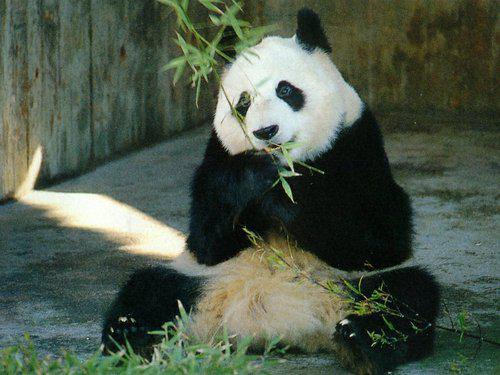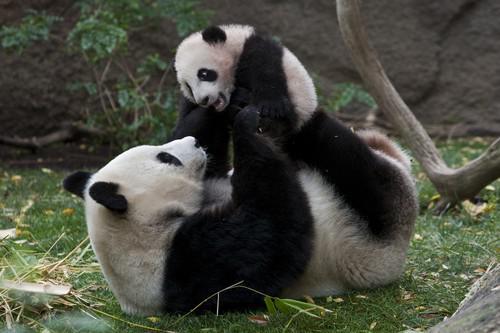The first image is the image on the left, the second image is the image on the right. For the images displayed, is the sentence "The right image shows two pandas." factually correct? Answer yes or no. Yes. 